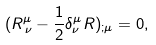<formula> <loc_0><loc_0><loc_500><loc_500>( R ^ { \mu } _ { \, \nu } - \frac { 1 } { 2 } \delta ^ { \mu } _ { \nu } R ) _ { ; \mu } = 0 ,</formula> 